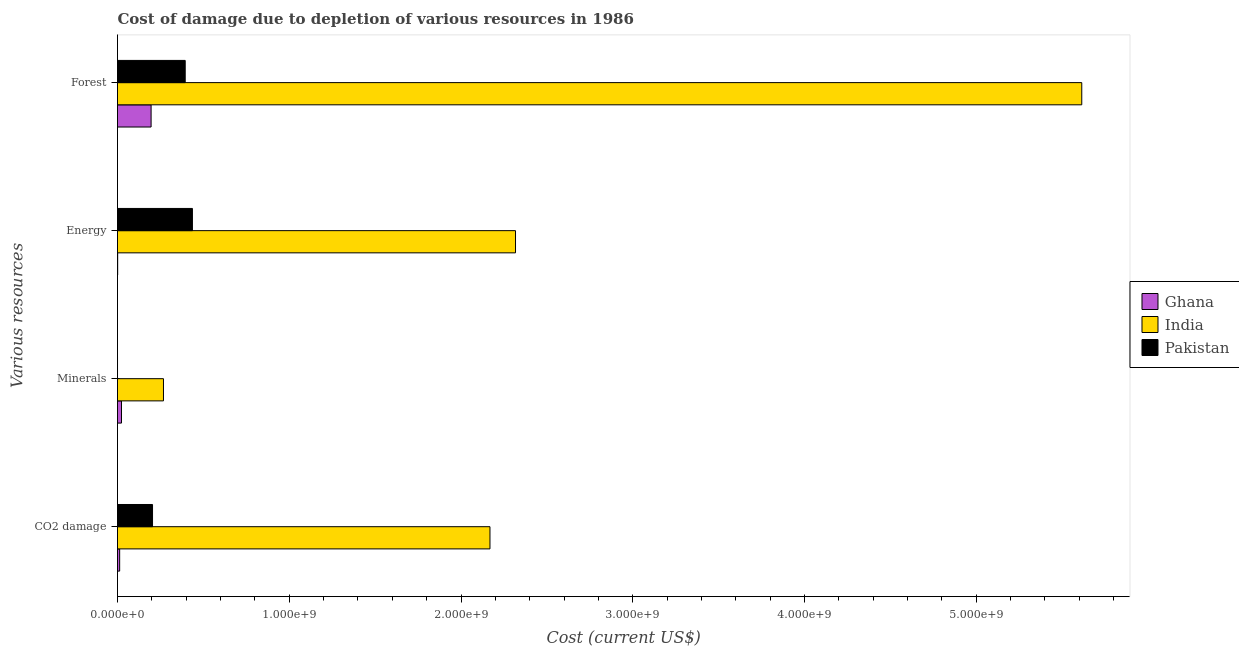How many different coloured bars are there?
Your answer should be compact. 3. Are the number of bars per tick equal to the number of legend labels?
Provide a succinct answer. Yes. Are the number of bars on each tick of the Y-axis equal?
Offer a terse response. Yes. What is the label of the 3rd group of bars from the top?
Your response must be concise. Minerals. What is the cost of damage due to depletion of forests in India?
Your response must be concise. 5.61e+09. Across all countries, what is the maximum cost of damage due to depletion of forests?
Keep it short and to the point. 5.61e+09. Across all countries, what is the minimum cost of damage due to depletion of minerals?
Keep it short and to the point. 3.43e+04. In which country was the cost of damage due to depletion of energy minimum?
Keep it short and to the point. Ghana. What is the total cost of damage due to depletion of energy in the graph?
Provide a succinct answer. 2.75e+09. What is the difference between the cost of damage due to depletion of forests in Ghana and that in India?
Keep it short and to the point. -5.42e+09. What is the difference between the cost of damage due to depletion of energy in Pakistan and the cost of damage due to depletion of forests in India?
Offer a terse response. -5.18e+09. What is the average cost of damage due to depletion of energy per country?
Give a very brief answer. 9.18e+08. What is the difference between the cost of damage due to depletion of forests and cost of damage due to depletion of coal in Ghana?
Offer a very short reply. 1.83e+08. What is the ratio of the cost of damage due to depletion of minerals in India to that in Ghana?
Provide a succinct answer. 11.52. What is the difference between the highest and the second highest cost of damage due to depletion of coal?
Your answer should be very brief. 1.96e+09. What is the difference between the highest and the lowest cost of damage due to depletion of energy?
Your answer should be compact. 2.32e+09. In how many countries, is the cost of damage due to depletion of minerals greater than the average cost of damage due to depletion of minerals taken over all countries?
Keep it short and to the point. 1. Is it the case that in every country, the sum of the cost of damage due to depletion of minerals and cost of damage due to depletion of energy is greater than the sum of cost of damage due to depletion of forests and cost of damage due to depletion of coal?
Make the answer very short. No. Is it the case that in every country, the sum of the cost of damage due to depletion of coal and cost of damage due to depletion of minerals is greater than the cost of damage due to depletion of energy?
Offer a terse response. No. How many bars are there?
Make the answer very short. 12. Are all the bars in the graph horizontal?
Your answer should be very brief. Yes. Are the values on the major ticks of X-axis written in scientific E-notation?
Your answer should be very brief. Yes. Does the graph contain any zero values?
Offer a terse response. No. Does the graph contain grids?
Give a very brief answer. No. Where does the legend appear in the graph?
Give a very brief answer. Center right. What is the title of the graph?
Offer a terse response. Cost of damage due to depletion of various resources in 1986 . What is the label or title of the X-axis?
Your answer should be compact. Cost (current US$). What is the label or title of the Y-axis?
Your response must be concise. Various resources. What is the Cost (current US$) in Ghana in CO2 damage?
Your answer should be compact. 1.26e+07. What is the Cost (current US$) in India in CO2 damage?
Provide a short and direct response. 2.17e+09. What is the Cost (current US$) of Pakistan in CO2 damage?
Keep it short and to the point. 2.04e+08. What is the Cost (current US$) in Ghana in Minerals?
Provide a short and direct response. 2.32e+07. What is the Cost (current US$) in India in Minerals?
Offer a very short reply. 2.68e+08. What is the Cost (current US$) in Pakistan in Minerals?
Your answer should be very brief. 3.43e+04. What is the Cost (current US$) in Ghana in Energy?
Your answer should be very brief. 9.63e+05. What is the Cost (current US$) of India in Energy?
Keep it short and to the point. 2.32e+09. What is the Cost (current US$) of Pakistan in Energy?
Ensure brevity in your answer.  4.36e+08. What is the Cost (current US$) of Ghana in Forest?
Offer a very short reply. 1.96e+08. What is the Cost (current US$) of India in Forest?
Give a very brief answer. 5.61e+09. What is the Cost (current US$) of Pakistan in Forest?
Offer a terse response. 3.94e+08. Across all Various resources, what is the maximum Cost (current US$) of Ghana?
Offer a very short reply. 1.96e+08. Across all Various resources, what is the maximum Cost (current US$) in India?
Your answer should be compact. 5.61e+09. Across all Various resources, what is the maximum Cost (current US$) in Pakistan?
Give a very brief answer. 4.36e+08. Across all Various resources, what is the minimum Cost (current US$) of Ghana?
Give a very brief answer. 9.63e+05. Across all Various resources, what is the minimum Cost (current US$) of India?
Provide a succinct answer. 2.68e+08. Across all Various resources, what is the minimum Cost (current US$) in Pakistan?
Provide a succinct answer. 3.43e+04. What is the total Cost (current US$) of Ghana in the graph?
Give a very brief answer. 2.32e+08. What is the total Cost (current US$) of India in the graph?
Your response must be concise. 1.04e+1. What is the total Cost (current US$) in Pakistan in the graph?
Give a very brief answer. 1.03e+09. What is the difference between the Cost (current US$) in Ghana in CO2 damage and that in Minerals?
Your response must be concise. -1.07e+07. What is the difference between the Cost (current US$) of India in CO2 damage and that in Minerals?
Offer a terse response. 1.90e+09. What is the difference between the Cost (current US$) of Pakistan in CO2 damage and that in Minerals?
Provide a short and direct response. 2.04e+08. What is the difference between the Cost (current US$) of Ghana in CO2 damage and that in Energy?
Offer a very short reply. 1.16e+07. What is the difference between the Cost (current US$) in India in CO2 damage and that in Energy?
Ensure brevity in your answer.  -1.49e+08. What is the difference between the Cost (current US$) in Pakistan in CO2 damage and that in Energy?
Ensure brevity in your answer.  -2.32e+08. What is the difference between the Cost (current US$) of Ghana in CO2 damage and that in Forest?
Your response must be concise. -1.83e+08. What is the difference between the Cost (current US$) of India in CO2 damage and that in Forest?
Your answer should be compact. -3.45e+09. What is the difference between the Cost (current US$) in Pakistan in CO2 damage and that in Forest?
Provide a short and direct response. -1.90e+08. What is the difference between the Cost (current US$) in Ghana in Minerals and that in Energy?
Ensure brevity in your answer.  2.23e+07. What is the difference between the Cost (current US$) of India in Minerals and that in Energy?
Provide a succinct answer. -2.05e+09. What is the difference between the Cost (current US$) in Pakistan in Minerals and that in Energy?
Offer a terse response. -4.36e+08. What is the difference between the Cost (current US$) in Ghana in Minerals and that in Forest?
Give a very brief answer. -1.72e+08. What is the difference between the Cost (current US$) in India in Minerals and that in Forest?
Your response must be concise. -5.35e+09. What is the difference between the Cost (current US$) in Pakistan in Minerals and that in Forest?
Your answer should be compact. -3.94e+08. What is the difference between the Cost (current US$) of Ghana in Energy and that in Forest?
Your answer should be very brief. -1.95e+08. What is the difference between the Cost (current US$) of India in Energy and that in Forest?
Your response must be concise. -3.30e+09. What is the difference between the Cost (current US$) in Pakistan in Energy and that in Forest?
Give a very brief answer. 4.20e+07. What is the difference between the Cost (current US$) in Ghana in CO2 damage and the Cost (current US$) in India in Minerals?
Keep it short and to the point. -2.55e+08. What is the difference between the Cost (current US$) in Ghana in CO2 damage and the Cost (current US$) in Pakistan in Minerals?
Ensure brevity in your answer.  1.25e+07. What is the difference between the Cost (current US$) of India in CO2 damage and the Cost (current US$) of Pakistan in Minerals?
Provide a succinct answer. 2.17e+09. What is the difference between the Cost (current US$) in Ghana in CO2 damage and the Cost (current US$) in India in Energy?
Ensure brevity in your answer.  -2.30e+09. What is the difference between the Cost (current US$) in Ghana in CO2 damage and the Cost (current US$) in Pakistan in Energy?
Your answer should be very brief. -4.24e+08. What is the difference between the Cost (current US$) of India in CO2 damage and the Cost (current US$) of Pakistan in Energy?
Your response must be concise. 1.73e+09. What is the difference between the Cost (current US$) of Ghana in CO2 damage and the Cost (current US$) of India in Forest?
Offer a terse response. -5.60e+09. What is the difference between the Cost (current US$) in Ghana in CO2 damage and the Cost (current US$) in Pakistan in Forest?
Your response must be concise. -3.82e+08. What is the difference between the Cost (current US$) of India in CO2 damage and the Cost (current US$) of Pakistan in Forest?
Ensure brevity in your answer.  1.77e+09. What is the difference between the Cost (current US$) of Ghana in Minerals and the Cost (current US$) of India in Energy?
Your answer should be compact. -2.29e+09. What is the difference between the Cost (current US$) in Ghana in Minerals and the Cost (current US$) in Pakistan in Energy?
Provide a succinct answer. -4.13e+08. What is the difference between the Cost (current US$) of India in Minerals and the Cost (current US$) of Pakistan in Energy?
Provide a short and direct response. -1.69e+08. What is the difference between the Cost (current US$) in Ghana in Minerals and the Cost (current US$) in India in Forest?
Offer a very short reply. -5.59e+09. What is the difference between the Cost (current US$) of Ghana in Minerals and the Cost (current US$) of Pakistan in Forest?
Give a very brief answer. -3.71e+08. What is the difference between the Cost (current US$) of India in Minerals and the Cost (current US$) of Pakistan in Forest?
Your answer should be very brief. -1.27e+08. What is the difference between the Cost (current US$) in Ghana in Energy and the Cost (current US$) in India in Forest?
Your answer should be very brief. -5.61e+09. What is the difference between the Cost (current US$) of Ghana in Energy and the Cost (current US$) of Pakistan in Forest?
Ensure brevity in your answer.  -3.93e+08. What is the difference between the Cost (current US$) of India in Energy and the Cost (current US$) of Pakistan in Forest?
Keep it short and to the point. 1.92e+09. What is the average Cost (current US$) of Ghana per Various resources?
Keep it short and to the point. 5.81e+07. What is the average Cost (current US$) in India per Various resources?
Provide a succinct answer. 2.59e+09. What is the average Cost (current US$) in Pakistan per Various resources?
Give a very brief answer. 2.59e+08. What is the difference between the Cost (current US$) of Ghana and Cost (current US$) of India in CO2 damage?
Offer a very short reply. -2.16e+09. What is the difference between the Cost (current US$) in Ghana and Cost (current US$) in Pakistan in CO2 damage?
Provide a succinct answer. -1.91e+08. What is the difference between the Cost (current US$) of India and Cost (current US$) of Pakistan in CO2 damage?
Provide a short and direct response. 1.96e+09. What is the difference between the Cost (current US$) of Ghana and Cost (current US$) of India in Minerals?
Provide a succinct answer. -2.44e+08. What is the difference between the Cost (current US$) of Ghana and Cost (current US$) of Pakistan in Minerals?
Make the answer very short. 2.32e+07. What is the difference between the Cost (current US$) of India and Cost (current US$) of Pakistan in Minerals?
Your response must be concise. 2.68e+08. What is the difference between the Cost (current US$) of Ghana and Cost (current US$) of India in Energy?
Keep it short and to the point. -2.32e+09. What is the difference between the Cost (current US$) of Ghana and Cost (current US$) of Pakistan in Energy?
Your answer should be very brief. -4.35e+08. What is the difference between the Cost (current US$) of India and Cost (current US$) of Pakistan in Energy?
Your answer should be very brief. 1.88e+09. What is the difference between the Cost (current US$) in Ghana and Cost (current US$) in India in Forest?
Ensure brevity in your answer.  -5.42e+09. What is the difference between the Cost (current US$) in Ghana and Cost (current US$) in Pakistan in Forest?
Make the answer very short. -1.99e+08. What is the difference between the Cost (current US$) of India and Cost (current US$) of Pakistan in Forest?
Your response must be concise. 5.22e+09. What is the ratio of the Cost (current US$) of Ghana in CO2 damage to that in Minerals?
Your response must be concise. 0.54. What is the ratio of the Cost (current US$) in India in CO2 damage to that in Minerals?
Give a very brief answer. 8.1. What is the ratio of the Cost (current US$) of Pakistan in CO2 damage to that in Minerals?
Provide a succinct answer. 5944.03. What is the ratio of the Cost (current US$) of Ghana in CO2 damage to that in Energy?
Your response must be concise. 13.05. What is the ratio of the Cost (current US$) in India in CO2 damage to that in Energy?
Offer a very short reply. 0.94. What is the ratio of the Cost (current US$) of Pakistan in CO2 damage to that in Energy?
Your answer should be compact. 0.47. What is the ratio of the Cost (current US$) in Ghana in CO2 damage to that in Forest?
Give a very brief answer. 0.06. What is the ratio of the Cost (current US$) of India in CO2 damage to that in Forest?
Offer a very short reply. 0.39. What is the ratio of the Cost (current US$) of Pakistan in CO2 damage to that in Forest?
Offer a terse response. 0.52. What is the ratio of the Cost (current US$) in Ghana in Minerals to that in Energy?
Ensure brevity in your answer.  24.14. What is the ratio of the Cost (current US$) of India in Minerals to that in Energy?
Your answer should be compact. 0.12. What is the ratio of the Cost (current US$) of Ghana in Minerals to that in Forest?
Your answer should be compact. 0.12. What is the ratio of the Cost (current US$) in India in Minerals to that in Forest?
Ensure brevity in your answer.  0.05. What is the ratio of the Cost (current US$) in Ghana in Energy to that in Forest?
Ensure brevity in your answer.  0. What is the ratio of the Cost (current US$) in India in Energy to that in Forest?
Your response must be concise. 0.41. What is the ratio of the Cost (current US$) of Pakistan in Energy to that in Forest?
Give a very brief answer. 1.11. What is the difference between the highest and the second highest Cost (current US$) of Ghana?
Ensure brevity in your answer.  1.72e+08. What is the difference between the highest and the second highest Cost (current US$) in India?
Offer a terse response. 3.30e+09. What is the difference between the highest and the second highest Cost (current US$) in Pakistan?
Keep it short and to the point. 4.20e+07. What is the difference between the highest and the lowest Cost (current US$) in Ghana?
Your response must be concise. 1.95e+08. What is the difference between the highest and the lowest Cost (current US$) in India?
Your answer should be very brief. 5.35e+09. What is the difference between the highest and the lowest Cost (current US$) in Pakistan?
Your answer should be compact. 4.36e+08. 